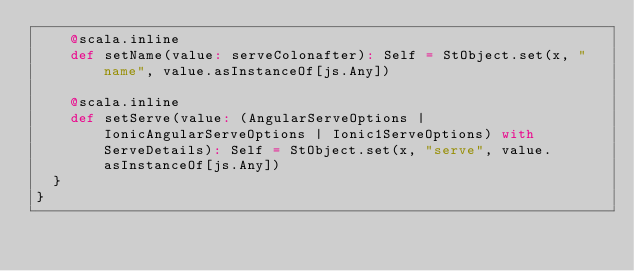<code> <loc_0><loc_0><loc_500><loc_500><_Scala_>    @scala.inline
    def setName(value: serveColonafter): Self = StObject.set(x, "name", value.asInstanceOf[js.Any])
    
    @scala.inline
    def setServe(value: (AngularServeOptions | IonicAngularServeOptions | Ionic1ServeOptions) with ServeDetails): Self = StObject.set(x, "serve", value.asInstanceOf[js.Any])
  }
}
</code> 